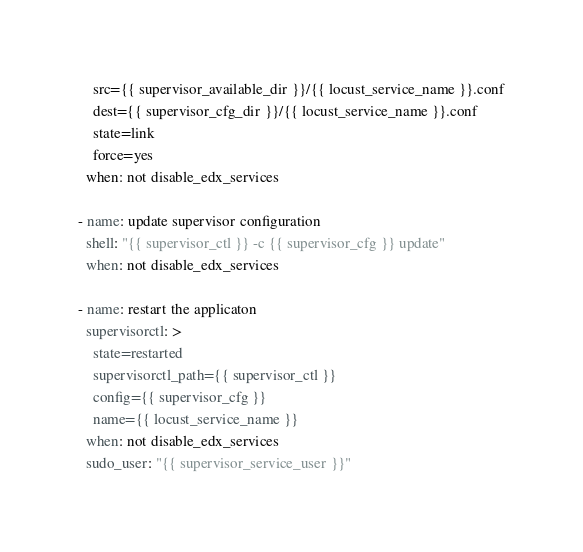<code> <loc_0><loc_0><loc_500><loc_500><_YAML_>    src={{ supervisor_available_dir }}/{{ locust_service_name }}.conf
    dest={{ supervisor_cfg_dir }}/{{ locust_service_name }}.conf
    state=link
    force=yes
  when: not disable_edx_services

- name: update supervisor configuration
  shell: "{{ supervisor_ctl }} -c {{ supervisor_cfg }} update"
  when: not disable_edx_services

- name: restart the applicaton
  supervisorctl: >
    state=restarted
    supervisorctl_path={{ supervisor_ctl }}
    config={{ supervisor_cfg }}
    name={{ locust_service_name }}
  when: not disable_edx_services
  sudo_user: "{{ supervisor_service_user }}"
</code> 